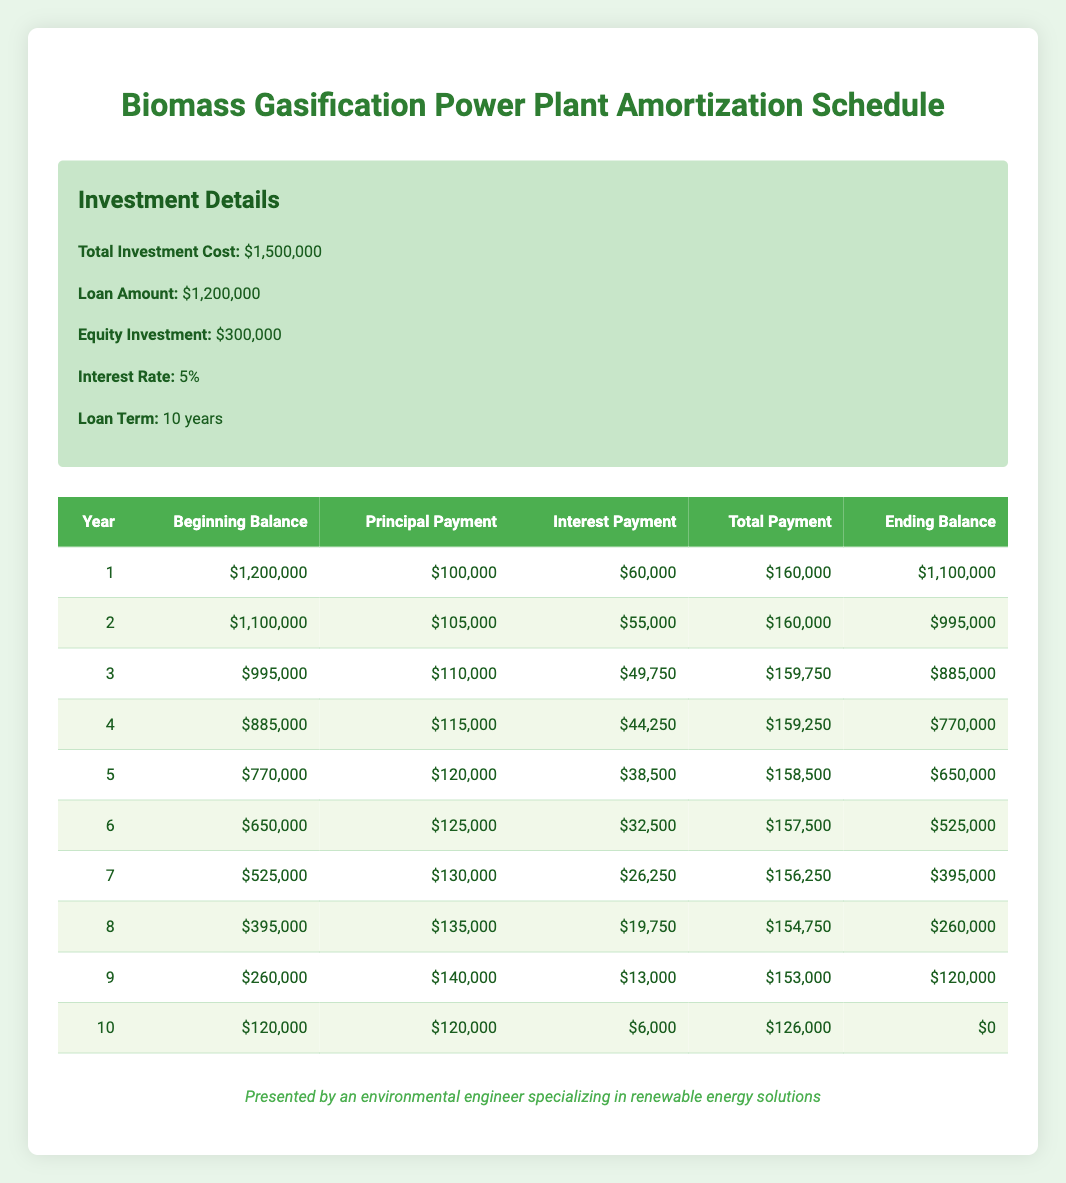What is the total investment cost for the biomass energy system? The total investment cost is explicitly listed in the information section as 1,500,000.
Answer: 1,500,000 In year 6, what was the beginning balance of the loan? In year 6, the table shows the beginning balance column, which states the value of 650,000.
Answer: 650,000 What was the total payment made in year 3? Looking at the total payment column for year 3, it indicates a total payment of 159,750.
Answer: 159,750 What is the total interest payment made over the entire loan period? By summing up all the interest payments from each year in the table, the calculation is as follows: 60,000 + 55,000 + 49,750 + 44,250 + 38,500 + 32,500 + 26,250 + 19,750 + 13,000 + 6,000 = 344,250.
Answer: 344,250 Is the principal payment in year 8 greater than the interest payment in the same year? For year 8, the principal payment is 135,000, while the interest payment is 19,750. Since 135,000 is greater than 19,750, the statement is true.
Answer: Yes What is the average annual principal payment during the loan term? To find the average, first sum the principal payments: 100,000 + 105,000 + 110,000 + 115,000 + 120,000 + 125,000 + 130,000 + 135,000 + 140,000 + 120,000 = 1,275,000. There are 10 years, so the average is 1,275,000 divided by 10 = 127,500.
Answer: 127,500 By how much does the ending balance decrease from year 1 to year 2? The ending balance for year 1 is 1,100,000 and for year 2, it is 995,000. The decrease can be calculated as 1,100,000 - 995,000 = 105,000.
Answer: 105,000 Is the total payment in year 5 less than the total payment in year 4? In year 4, the total payment is 159,250, while in year 5 it is 158,500. Since 158,500 is less than 159,250, the statement is true.
Answer: Yes What is the loan balance at the end of year 10? According to the table, the ending balance for year 10 is 0, indicating that the loan has been fully paid off.
Answer: 0 